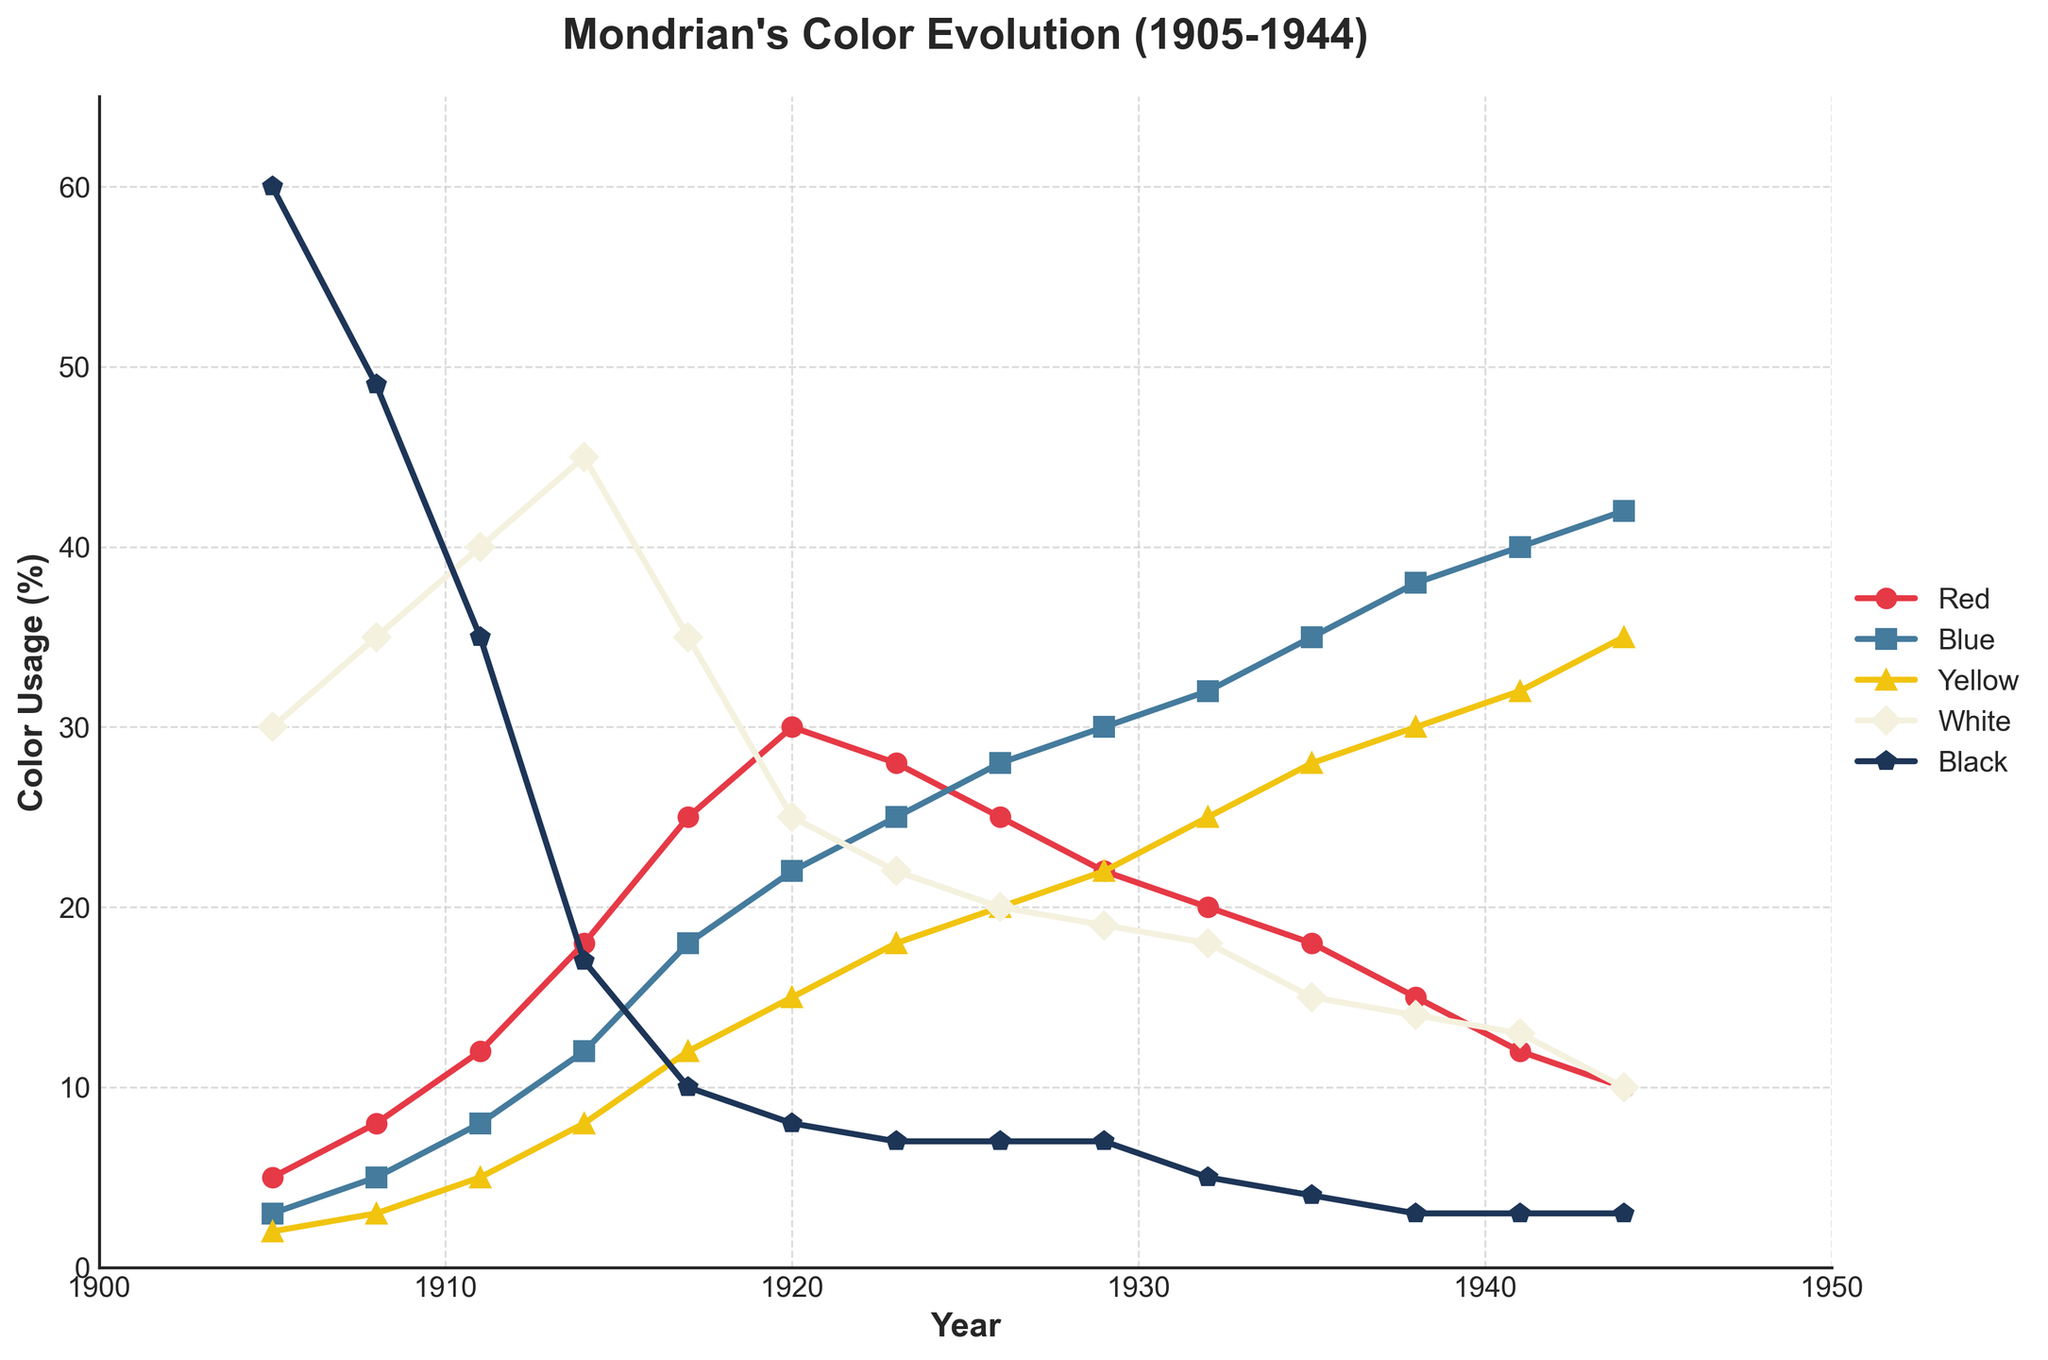What is the trend for the usage of the color blue from 1905 to 1944? The line representing the blue color shows an increase over time, starting from 3% in 1905 and ending at 42% in 1944. The overall trend is a steady rise.
Answer: Increasing How does the usage of red compare to yellow in 1932? In 1932, the red usage is at 20%, while the yellow usage is at 25%. Thus, yellow usage is higher than red in that year.
Answer: Yellow is higher Which year saw the highest usage of white? By examining the data, it's clear that the highest usage of white color occurred in 1914, reaching 45%.
Answer: 1914 What is the combined usage percentage of red and black in 1926? In 1926, red is at 25% and black is at 7%. So, the combined usage is 25% + 7% = 32%.
Answer: 32% Between which years did the usage of black fall below 10% for the first time? Black usage fell below 10% in 1917 when it dropped to 10%, and further down to 8% in 1920. Therefore, the first instance was between 1914 and 1917.
Answer: Between 1914 and 1917 What color's usage remained relatively stable between 1923 and 1944, fluctuating the least? The white color shows minimal fluctuations, remaining between 22% in 1923 and 10% in 1944, with the change being relatively minor compared to other colors.
Answer: White What was the average usage of yellow between 1911 and 1944? The yellow usages are: 5, 8, 12, 15, 18, 20, 22, 25, 28, 30, 32, 35. The sum of these values is 250, and there are 12 values. So, the average is 250 / 12 ≈ 20.83%.
Answer: 20.83% Which color shows the most dramatic increase between any two consecutive data points? Blue shows a dramatic increase between 1905 and 1908, going from 3% to 5%, an increase of 2%. This continued trend shows the most significant stepwise increase.
Answer: Blue During which period did the usage of red decrease the fastest? The most rapid decrease in red usage occurred between 1935 and 1944, descending from 18% to 10%.
Answer: 1935 to 1944 How does the usage of blue in 1938 compare to its usage in 1941? Blue usage in 1938 is at 38%, while it is at 40% in 1941, indicating an increase.
Answer: 1941 is higher 